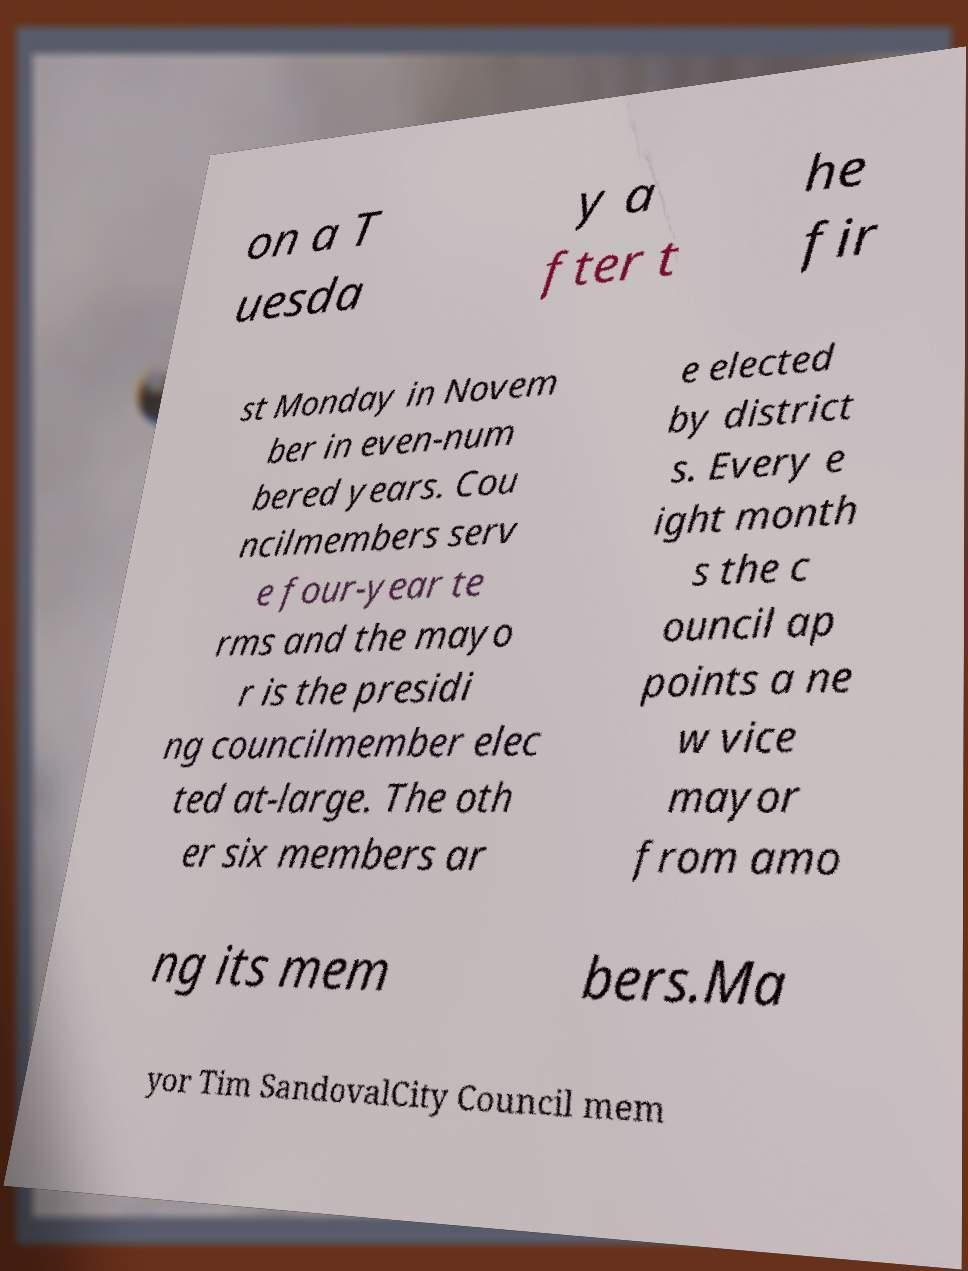Can you read and provide the text displayed in the image?This photo seems to have some interesting text. Can you extract and type it out for me? on a T uesda y a fter t he fir st Monday in Novem ber in even-num bered years. Cou ncilmembers serv e four-year te rms and the mayo r is the presidi ng councilmember elec ted at-large. The oth er six members ar e elected by district s. Every e ight month s the c ouncil ap points a ne w vice mayor from amo ng its mem bers.Ma yor Tim SandovalCity Council mem 